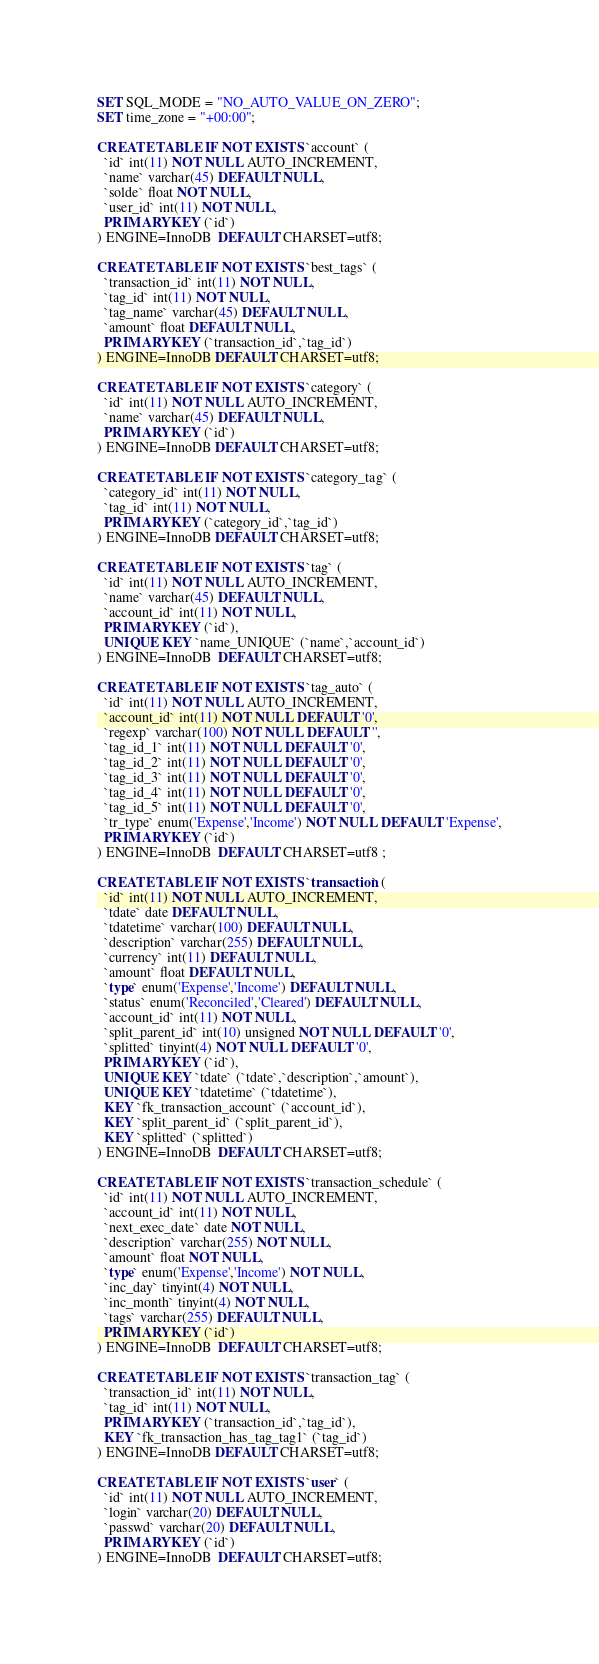Convert code to text. <code><loc_0><loc_0><loc_500><loc_500><_SQL_>SET SQL_MODE = "NO_AUTO_VALUE_ON_ZERO";
SET time_zone = "+00:00";

CREATE TABLE IF NOT EXISTS `account` (
  `id` int(11) NOT NULL AUTO_INCREMENT,
  `name` varchar(45) DEFAULT NULL,
  `solde` float NOT NULL,
  `user_id` int(11) NOT NULL,
  PRIMARY KEY (`id`)
) ENGINE=InnoDB  DEFAULT CHARSET=utf8;

CREATE TABLE IF NOT EXISTS `best_tags` (
  `transaction_id` int(11) NOT NULL,
  `tag_id` int(11) NOT NULL,
  `tag_name` varchar(45) DEFAULT NULL,
  `amount` float DEFAULT NULL,
  PRIMARY KEY (`transaction_id`,`tag_id`)
) ENGINE=InnoDB DEFAULT CHARSET=utf8;

CREATE TABLE IF NOT EXISTS `category` (
  `id` int(11) NOT NULL AUTO_INCREMENT,
  `name` varchar(45) DEFAULT NULL,
  PRIMARY KEY (`id`)
) ENGINE=InnoDB DEFAULT CHARSET=utf8;

CREATE TABLE IF NOT EXISTS `category_tag` (
  `category_id` int(11) NOT NULL,
  `tag_id` int(11) NOT NULL,
  PRIMARY KEY (`category_id`,`tag_id`)
) ENGINE=InnoDB DEFAULT CHARSET=utf8;

CREATE TABLE IF NOT EXISTS `tag` (
  `id` int(11) NOT NULL AUTO_INCREMENT,
  `name` varchar(45) DEFAULT NULL,
  `account_id` int(11) NOT NULL,
  PRIMARY KEY (`id`),
  UNIQUE KEY `name_UNIQUE` (`name`,`account_id`)
) ENGINE=InnoDB  DEFAULT CHARSET=utf8;

CREATE TABLE IF NOT EXISTS `tag_auto` (
  `id` int(11) NOT NULL AUTO_INCREMENT,
  `account_id` int(11) NOT NULL DEFAULT '0',
  `regexp` varchar(100) NOT NULL DEFAULT '',
  `tag_id_1` int(11) NOT NULL DEFAULT '0',
  `tag_id_2` int(11) NOT NULL DEFAULT '0',
  `tag_id_3` int(11) NOT NULL DEFAULT '0',
  `tag_id_4` int(11) NOT NULL DEFAULT '0',
  `tag_id_5` int(11) NOT NULL DEFAULT '0',
  `tr_type` enum('Expense','Income') NOT NULL DEFAULT 'Expense',
  PRIMARY KEY (`id`)
) ENGINE=InnoDB  DEFAULT CHARSET=utf8 ;

CREATE TABLE IF NOT EXISTS `transaction` (
  `id` int(11) NOT NULL AUTO_INCREMENT,
  `tdate` date DEFAULT NULL,
  `tdatetime` varchar(100) DEFAULT NULL,
  `description` varchar(255) DEFAULT NULL,
  `currency` int(11) DEFAULT NULL,
  `amount` float DEFAULT NULL,
  `type` enum('Expense','Income') DEFAULT NULL,
  `status` enum('Reconciled','Cleared') DEFAULT NULL,
  `account_id` int(11) NOT NULL,
  `split_parent_id` int(10) unsigned NOT NULL DEFAULT '0',
  `splitted` tinyint(4) NOT NULL DEFAULT '0',
  PRIMARY KEY (`id`),
  UNIQUE KEY `tdate` (`tdate`,`description`,`amount`),
  UNIQUE KEY `tdatetime` (`tdatetime`),
  KEY `fk_transaction_account` (`account_id`),
  KEY `split_parent_id` (`split_parent_id`),
  KEY `splitted` (`splitted`)
) ENGINE=InnoDB  DEFAULT CHARSET=utf8;

CREATE TABLE IF NOT EXISTS `transaction_schedule` (
  `id` int(11) NOT NULL AUTO_INCREMENT,
  `account_id` int(11) NOT NULL,
  `next_exec_date` date NOT NULL,
  `description` varchar(255) NOT NULL,
  `amount` float NOT NULL,
  `type` enum('Expense','Income') NOT NULL,
  `inc_day` tinyint(4) NOT NULL,
  `inc_month` tinyint(4) NOT NULL,
  `tags` varchar(255) DEFAULT NULL,
  PRIMARY KEY (`id`)
) ENGINE=InnoDB  DEFAULT CHARSET=utf8;

CREATE TABLE IF NOT EXISTS `transaction_tag` (
  `transaction_id` int(11) NOT NULL,
  `tag_id` int(11) NOT NULL,
  PRIMARY KEY (`transaction_id`,`tag_id`),
  KEY `fk_transaction_has_tag_tag1` (`tag_id`)
) ENGINE=InnoDB DEFAULT CHARSET=utf8;

CREATE TABLE IF NOT EXISTS `user` (
  `id` int(11) NOT NULL AUTO_INCREMENT,
  `login` varchar(20) DEFAULT NULL,
  `passwd` varchar(20) DEFAULT NULL,
  PRIMARY KEY (`id`)
) ENGINE=InnoDB  DEFAULT CHARSET=utf8;

</code> 